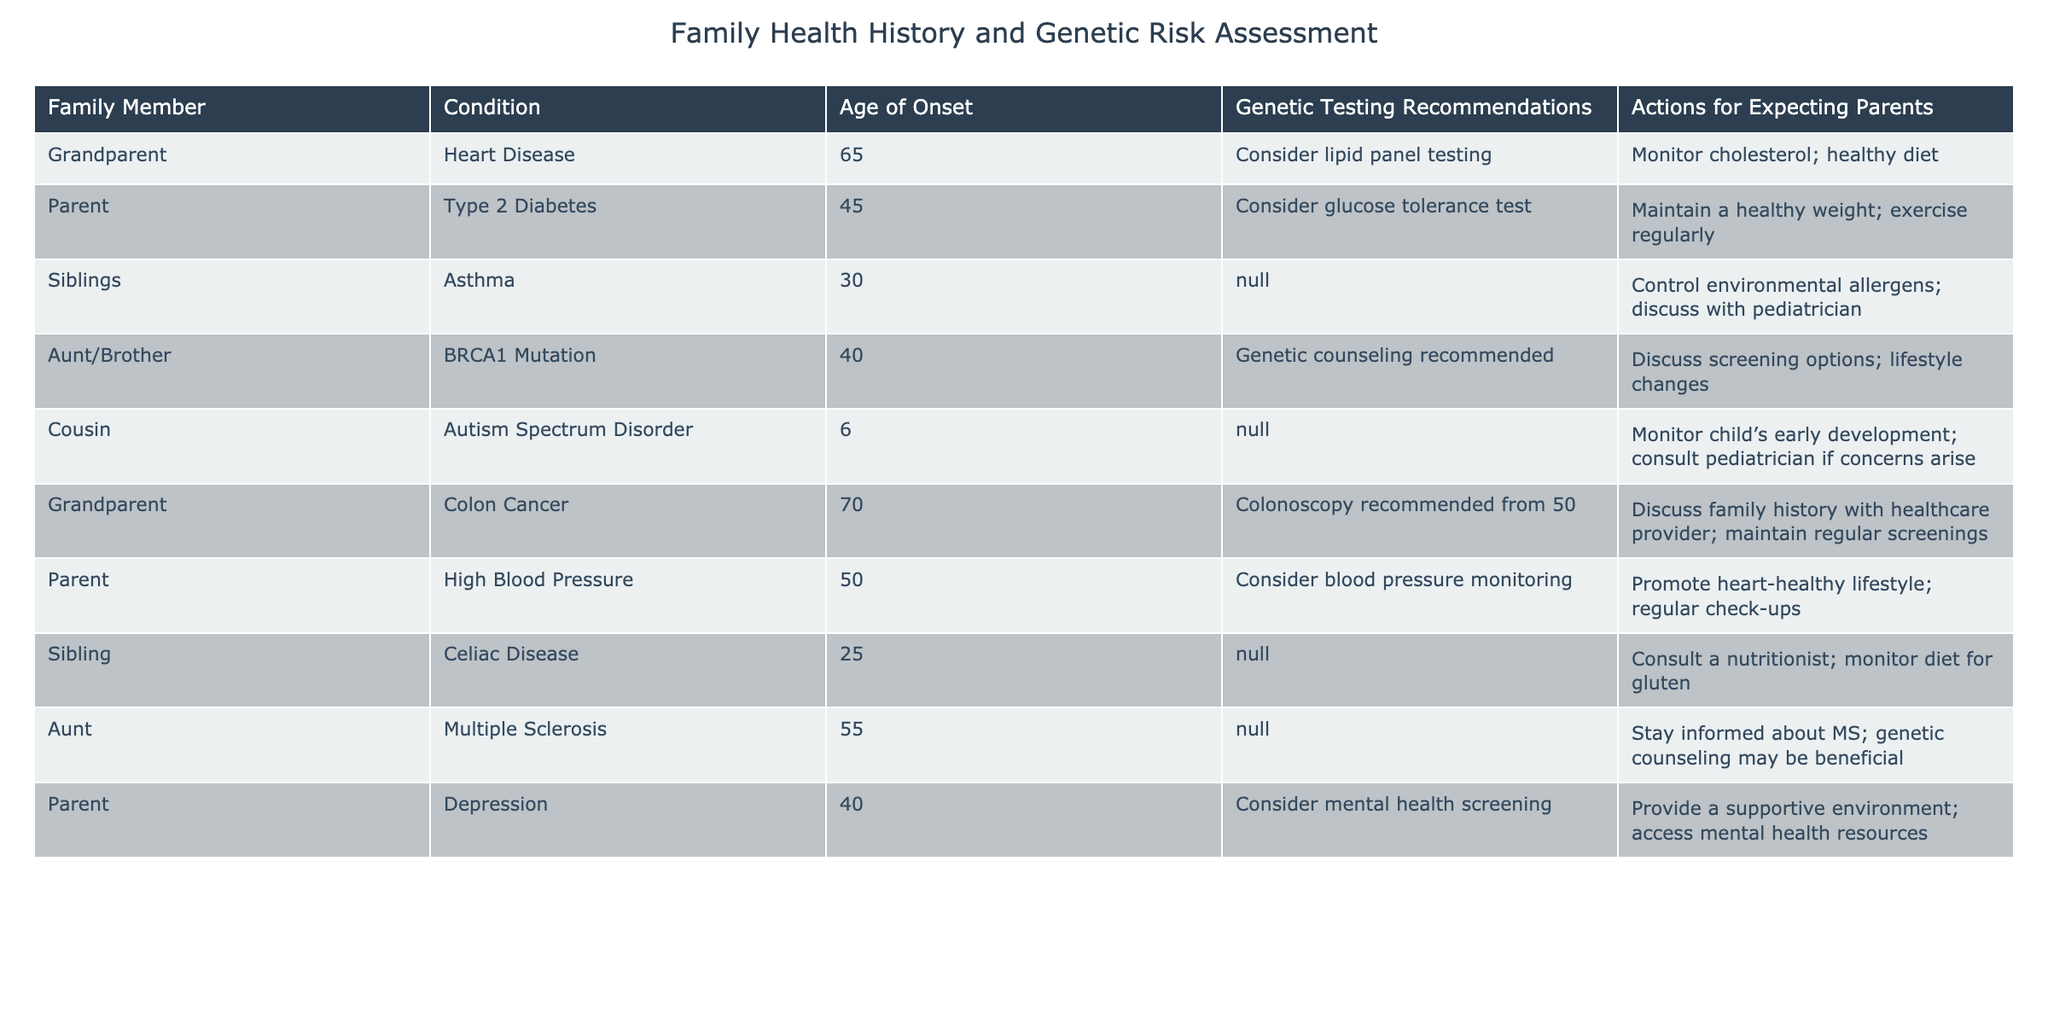What is the age of onset for Asthma in siblings? The table shows that the age of onset for Asthma is provided under the "Age of Onset" column for siblings, which is 30.
Answer: 30 Is genetic counseling recommended for a BRCA1 mutation? The table indicates that genetic counseling is recommended for the condition associated with a BRCA1 mutation. Therefore, the answer is yes.
Answer: Yes What health condition has the earliest age of onset listed? Looking at the "Age of Onset" column, the ages to compare are 65 (Heart Disease), 45 (Type 2 Diabetes), 30 (Asthma), 40 (BRCA1 Mutation), 6 (Autism Spectrum Disorder), 70 (Colon Cancer), 50 (High Blood Pressure), 25 (Celiac Disease), 55 (Multiple Sclerosis), and 40 (Depression). The earliest age of onset is 6 for Autism Spectrum Disorder.
Answer: 6 How many conditions listed have a genetic testing recommendation? Counting the conditions with a recommendation: Heart Disease, Type 2 Diabetes, BRCA1 Mutation, Colon Cancer, High Blood Pressure, and Depression. This gives a total of 6 conditions.
Answer: 6 What actions are suggested for expecting parents if a family member has Celiac Disease? The table specifies that for Celiac Disease, the suggested actions for expecting parents include consulting a nutritionist and monitoring the diet for gluten.
Answer: Consult a nutritionist; monitor diet for gluten If both parents have conditions, will they each provide health risks based on the family health history? The table mentions several conditions from parents which may pose health risks. Since both parents have health conditions, it is reasonable to say that they collectively can contribute to the health risks for their child. Therefore, the answer is yes.
Answer: Yes What is the difference between the ages of onset for Heart Disease and Colon Cancer? The onset age for Heart Disease is 65 and for Colon Cancer is 70. The difference is calculated as 70 - 65 = 5 years.
Answer: 5 What are the actions recommended for parents if there is a family history of depression? The table states that for depression, parents should provide a supportive environment and access mental health resources.
Answer: Provide a supportive environment; access mental health resources Which health condition has genetic testing recommended at the youngest age of onset? The youngest onset age with a genetic testing recommendation is for BRCA1 Mutation, which is 40 years old. The age of onset for conditions without recommendations is not considered.
Answer: 40 